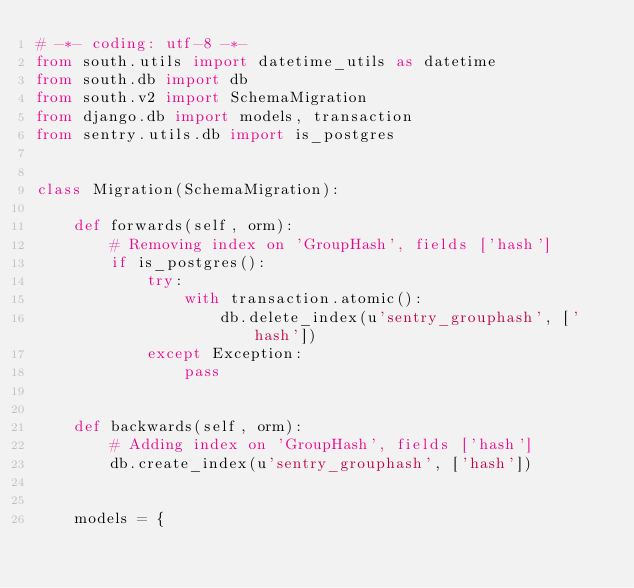<code> <loc_0><loc_0><loc_500><loc_500><_Python_># -*- coding: utf-8 -*-
from south.utils import datetime_utils as datetime
from south.db import db
from south.v2 import SchemaMigration
from django.db import models, transaction
from sentry.utils.db import is_postgres


class Migration(SchemaMigration):

    def forwards(self, orm):
        # Removing index on 'GroupHash', fields ['hash']
        if is_postgres():
            try:
                with transaction.atomic():
                    db.delete_index(u'sentry_grouphash', ['hash'])
            except Exception:
                pass


    def backwards(self, orm):
        # Adding index on 'GroupHash', fields ['hash']
        db.create_index(u'sentry_grouphash', ['hash'])


    models = {</code> 